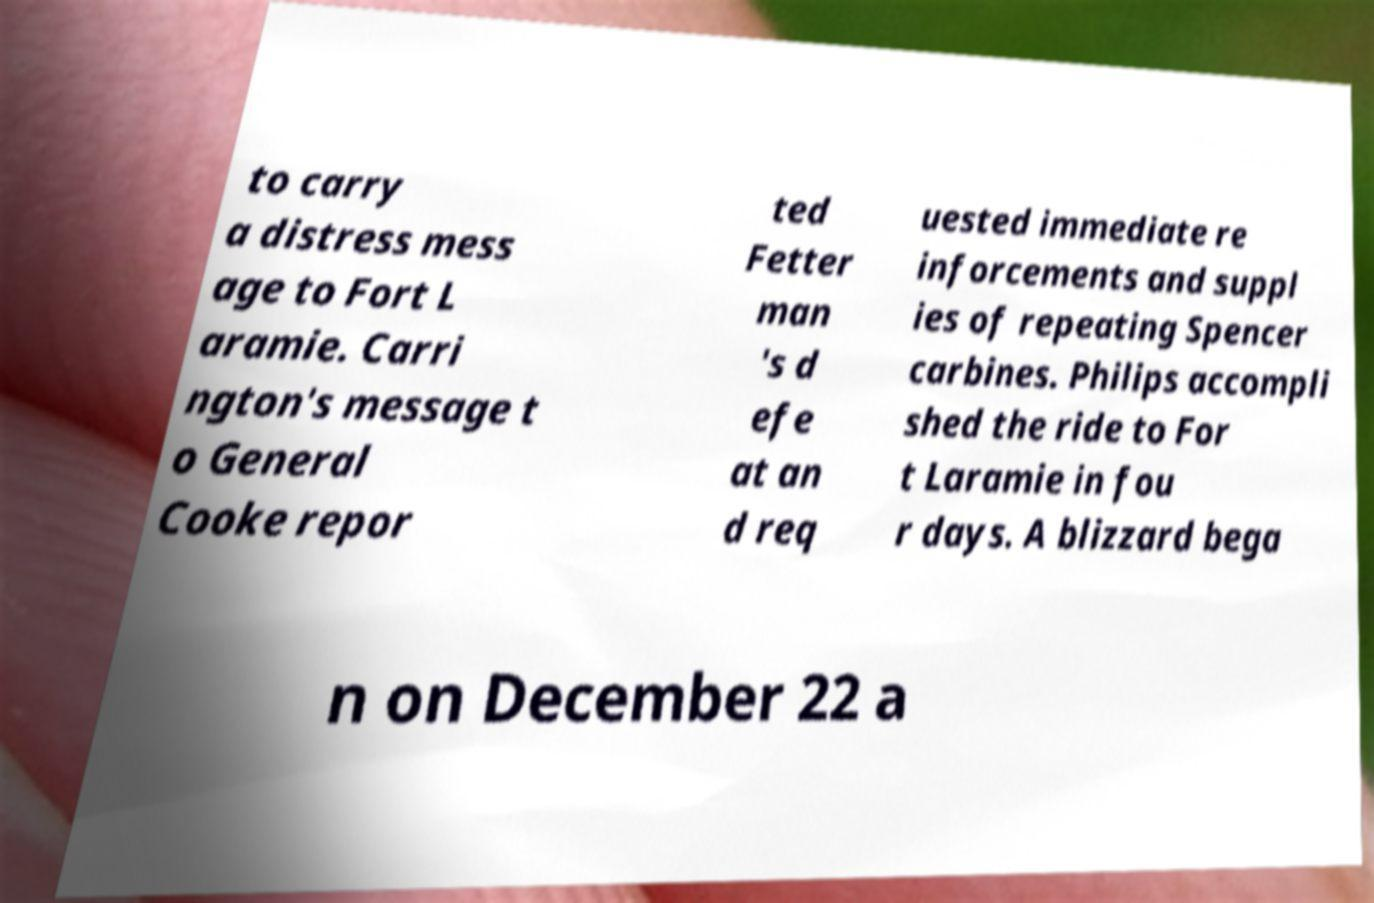I need the written content from this picture converted into text. Can you do that? to carry a distress mess age to Fort L aramie. Carri ngton's message t o General Cooke repor ted Fetter man 's d efe at an d req uested immediate re inforcements and suppl ies of repeating Spencer carbines. Philips accompli shed the ride to For t Laramie in fou r days. A blizzard bega n on December 22 a 